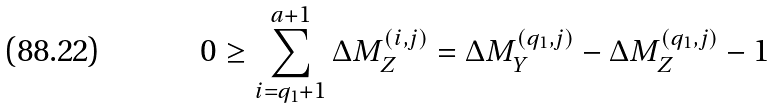Convert formula to latex. <formula><loc_0><loc_0><loc_500><loc_500>0 \geq \sum _ { i = q _ { 1 } + 1 } ^ { a + 1 } \Delta M _ { Z } ^ { ( i , j ) } = \Delta M _ { Y } ^ { ( q _ { 1 } , j ) } - \Delta M _ { Z } ^ { ( q _ { 1 } , j ) } - 1</formula> 